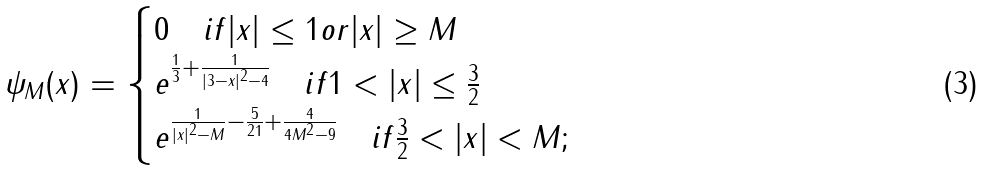<formula> <loc_0><loc_0><loc_500><loc_500>\psi _ { M } ( x ) = \begin{cases} 0 \quad i f | x | \leq 1 o r | x | \geq M \\ e ^ { \frac { 1 } { 3 } + \frac { 1 } { | 3 - x | ^ { 2 } - 4 } } \quad i f 1 < | x | \leq \frac { 3 } { 2 } \\ e ^ { \frac { 1 } { | x | ^ { 2 } - M } - \frac { 5 } { 2 1 } + \frac { 4 } { 4 M ^ { 2 } - 9 } } \quad i f \frac { 3 } { 2 } < | x | < M ; \end{cases}</formula> 